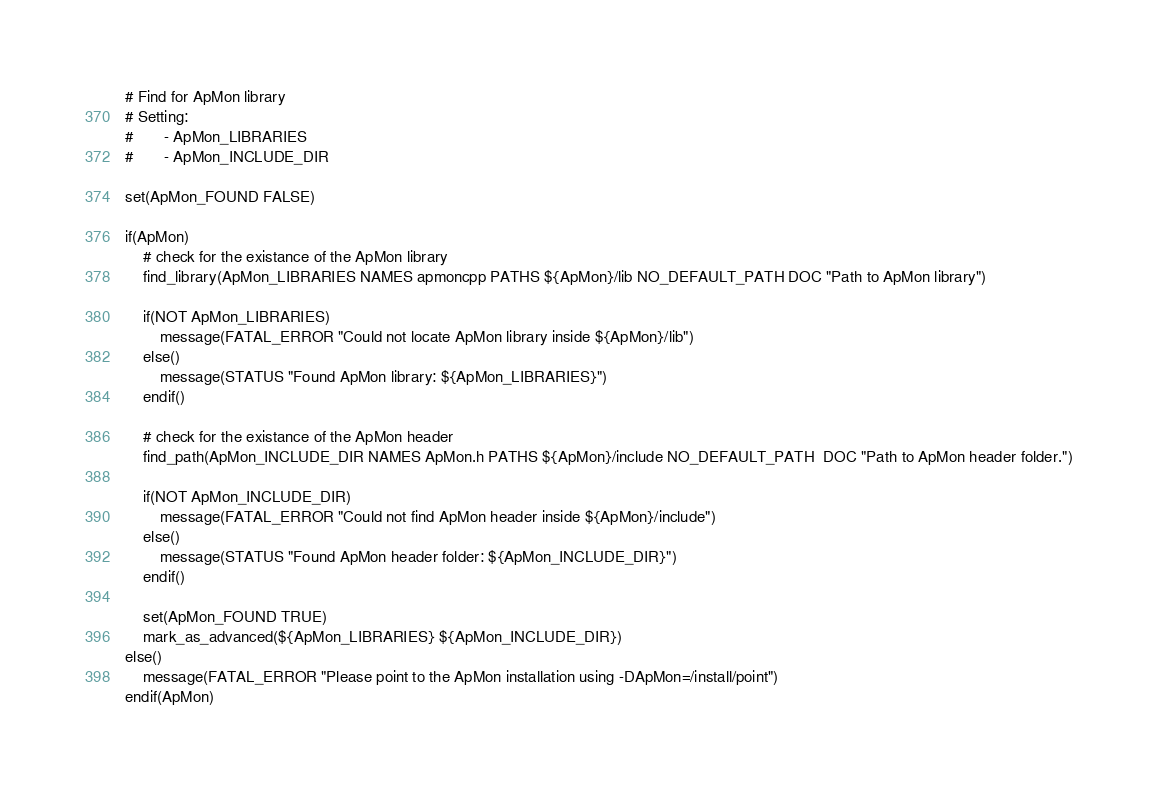<code> <loc_0><loc_0><loc_500><loc_500><_CMake_># Find for ApMon library
# Setting:
#       - ApMon_LIBRARIES
#       - ApMon_INCLUDE_DIR

set(ApMon_FOUND FALSE)

if(ApMon)
    # check for the existance of the ApMon library
    find_library(ApMon_LIBRARIES NAMES apmoncpp PATHS ${ApMon}/lib NO_DEFAULT_PATH DOC "Path to ApMon library")
    
    if(NOT ApMon_LIBRARIES)
        message(FATAL_ERROR "Could not locate ApMon library inside ${ApMon}/lib")
    else()
        message(STATUS "Found ApMon library: ${ApMon_LIBRARIES}")
    endif()
    
    # check for the existance of the ApMon header
    find_path(ApMon_INCLUDE_DIR NAMES ApMon.h PATHS ${ApMon}/include NO_DEFAULT_PATH  DOC "Path to ApMon header folder.")
    
    if(NOT ApMon_INCLUDE_DIR)
        message(FATAL_ERROR "Could not find ApMon header inside ${ApMon}/include")
    else()
        message(STATUS "Found ApMon header folder: ${ApMon_INCLUDE_DIR}")
    endif()

    set(ApMon_FOUND TRUE)
    mark_as_advanced(${ApMon_LIBRARIES} ${ApMon_INCLUDE_DIR})
else()
    message(FATAL_ERROR "Please point to the ApMon installation using -DApMon=/install/point")
endif(ApMon)</code> 